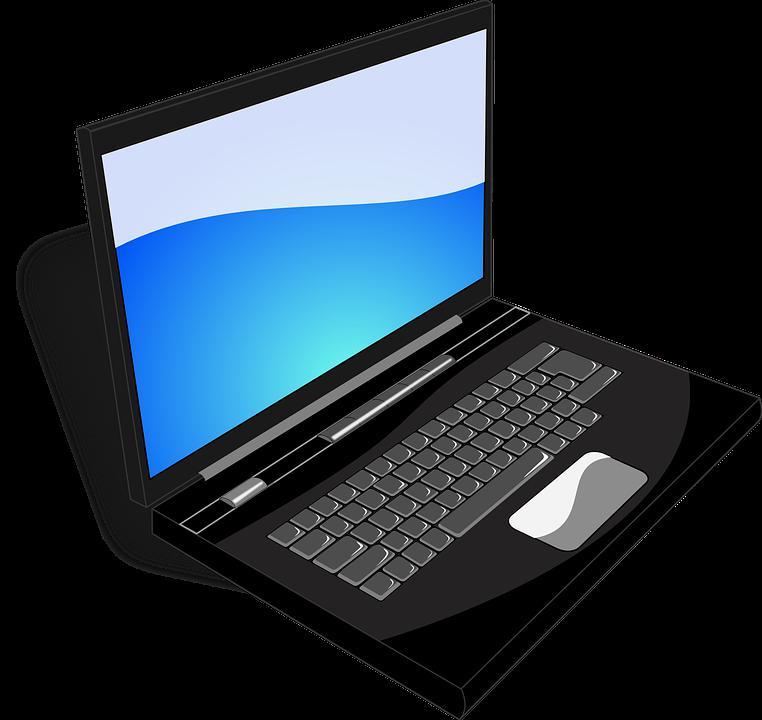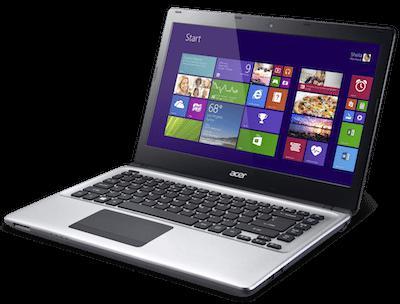The first image is the image on the left, the second image is the image on the right. Considering the images on both sides, is "Each image shows one opened laptop displayed turned at an angle." valid? Answer yes or no. Yes. The first image is the image on the left, the second image is the image on the right. Examine the images to the left and right. Is the description "Apps are shown on exactly one of the laptops." accurate? Answer yes or no. Yes. 